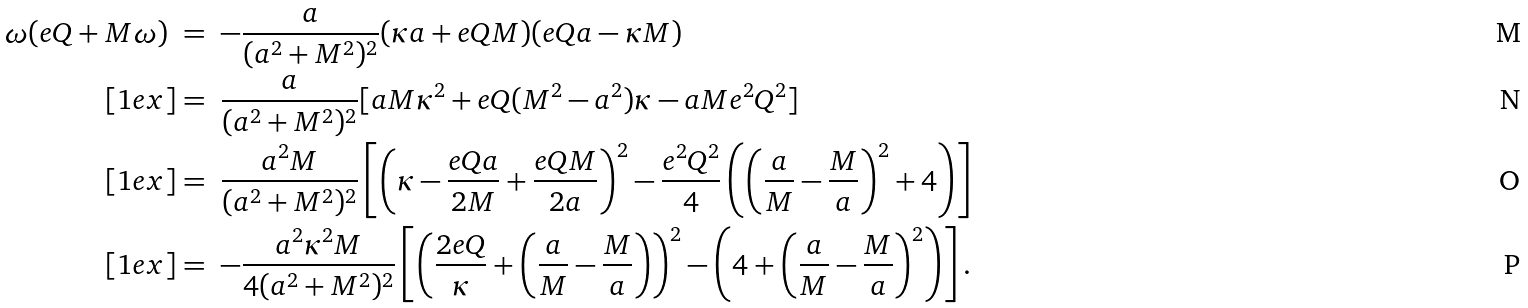Convert formula to latex. <formula><loc_0><loc_0><loc_500><loc_500>\omega ( e Q + M \omega ) \ & = \ - \frac { a } { ( a ^ { 2 } + M ^ { 2 } ) ^ { 2 } } ( \kappa a + e Q M ) ( e Q a - \kappa M ) \\ [ 1 e x ] & = \ \frac { a } { ( a ^ { 2 } + M ^ { 2 } ) ^ { 2 } } [ a M \kappa ^ { 2 } + e Q ( M ^ { 2 } - a ^ { 2 } ) \kappa - a M e ^ { 2 } Q ^ { 2 } ] \\ [ 1 e x ] & = \ \frac { a ^ { 2 } M } { ( a ^ { 2 } + M ^ { 2 } ) ^ { 2 } } \left [ \left ( \kappa - \frac { e Q a } { 2 M } + \frac { e Q M } { 2 a } \right ) ^ { 2 } - \frac { e ^ { 2 } Q ^ { 2 } } { 4 } \left ( \left ( \frac { a } { M } - \frac { M } { a } \right ) ^ { 2 } + 4 \right ) \right ] \\ [ 1 e x ] & = \ - \frac { a ^ { 2 } \kappa ^ { 2 } M } { 4 ( a ^ { 2 } + M ^ { 2 } ) ^ { 2 } } \left [ \left ( \frac { 2 e Q } { \kappa } + \left ( \frac { a } { M } - \frac { M } { a } \right ) \right ) ^ { 2 } - \left ( 4 + \left ( \frac { a } { M } - \frac { M } { a } \right ) ^ { 2 } \right ) \right ] .</formula> 